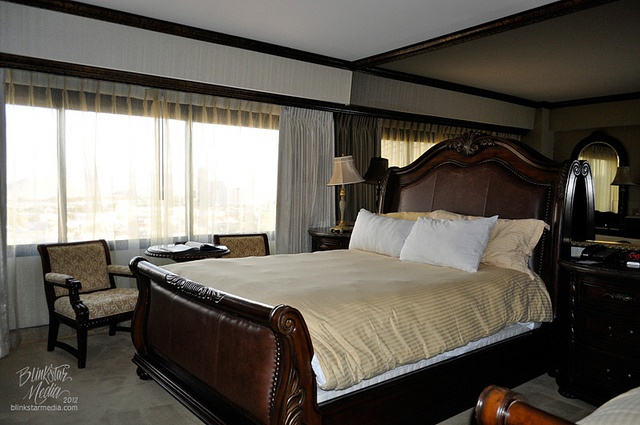Describe the objects in this image and their specific colors. I can see bed in black, darkgray, and gray tones, chair in black and gray tones, chair in black, maroon, and gray tones, couch in black and gray tones, and book in black, lightgray, darkgray, and gray tones in this image. 